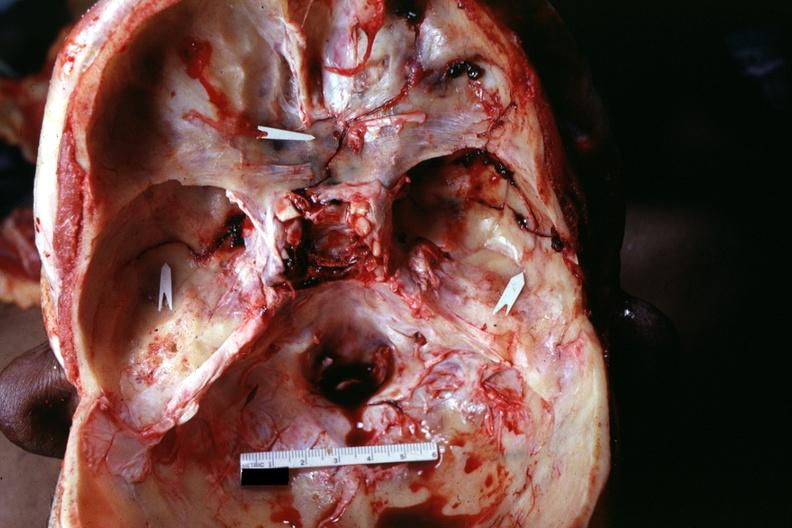what is present?
Answer the question using a single word or phrase. Basilar skull fracture 